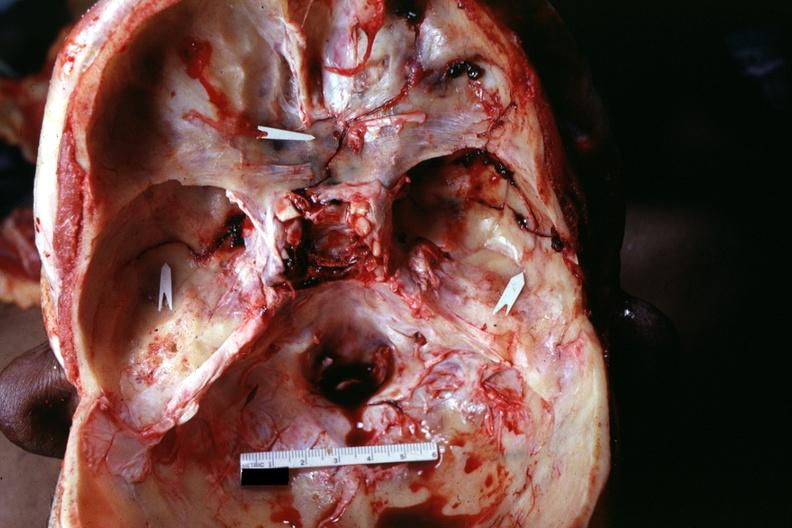what is present?
Answer the question using a single word or phrase. Basilar skull fracture 